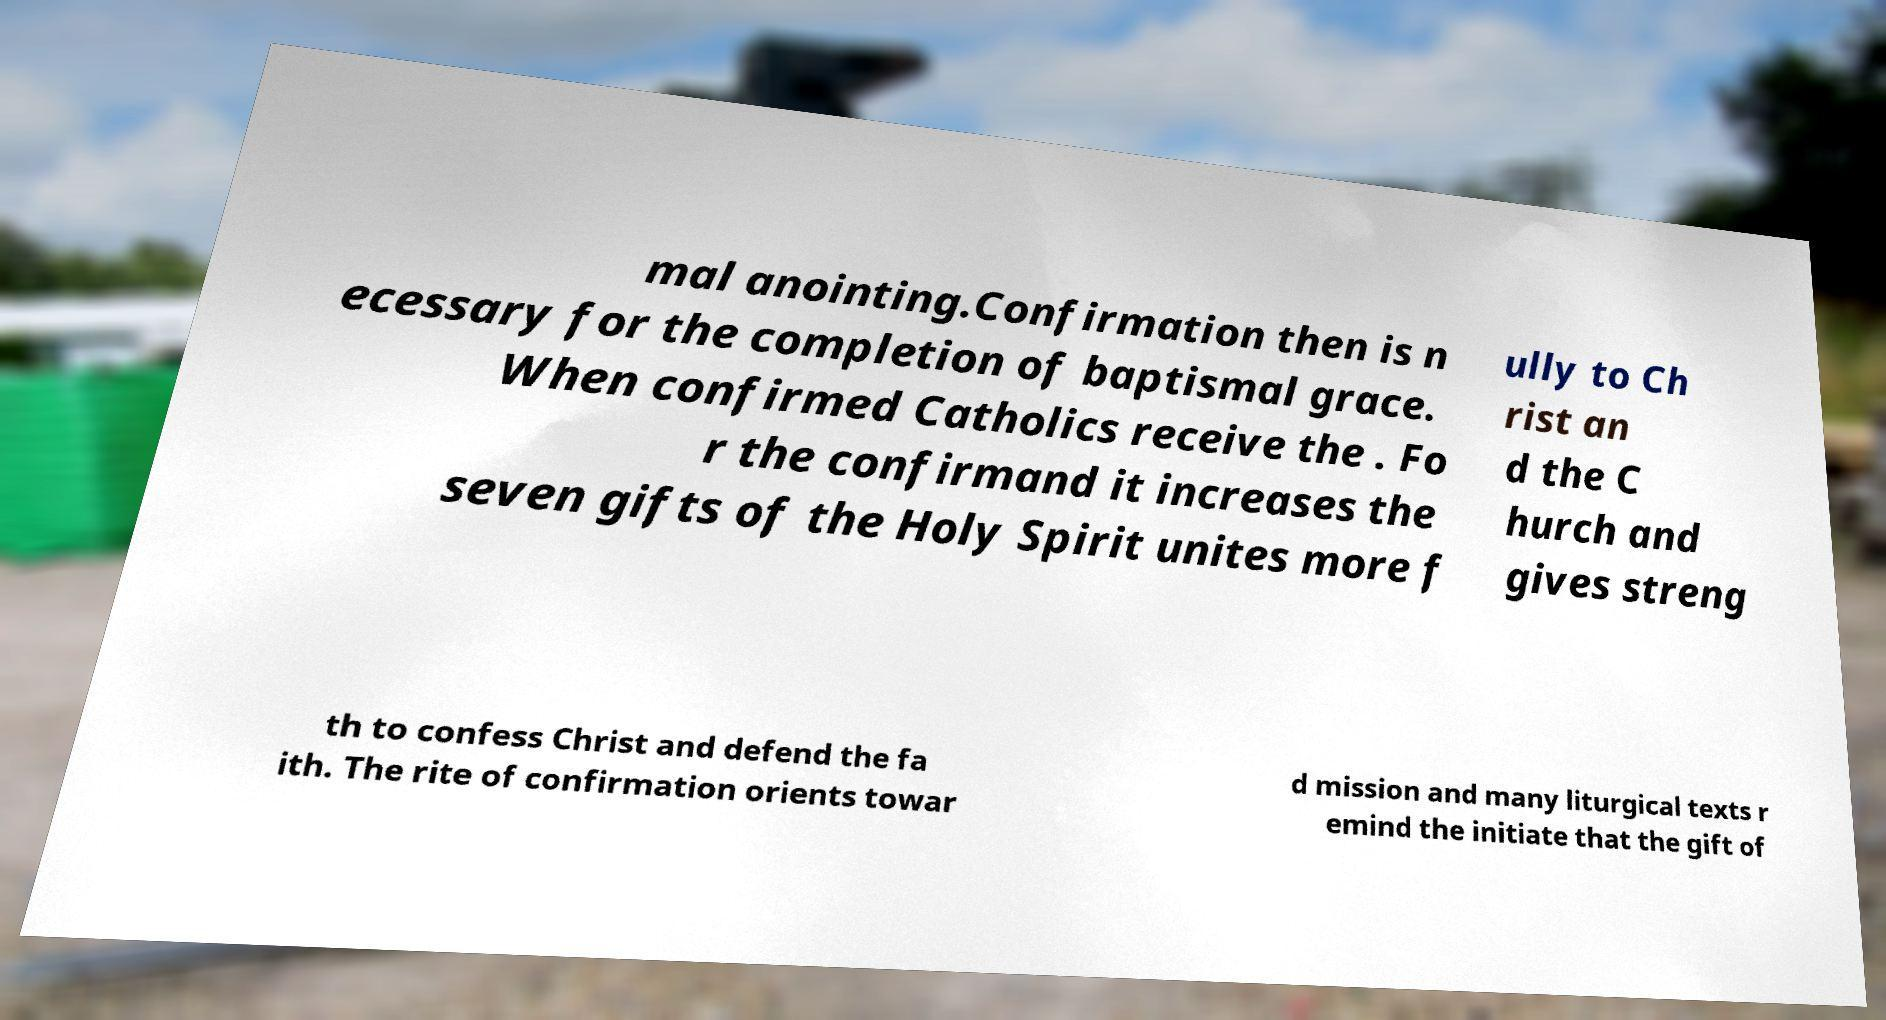Please read and relay the text visible in this image. What does it say? mal anointing.Confirmation then is n ecessary for the completion of baptismal grace. When confirmed Catholics receive the . Fo r the confirmand it increases the seven gifts of the Holy Spirit unites more f ully to Ch rist an d the C hurch and gives streng th to confess Christ and defend the fa ith. The rite of confirmation orients towar d mission and many liturgical texts r emind the initiate that the gift of 